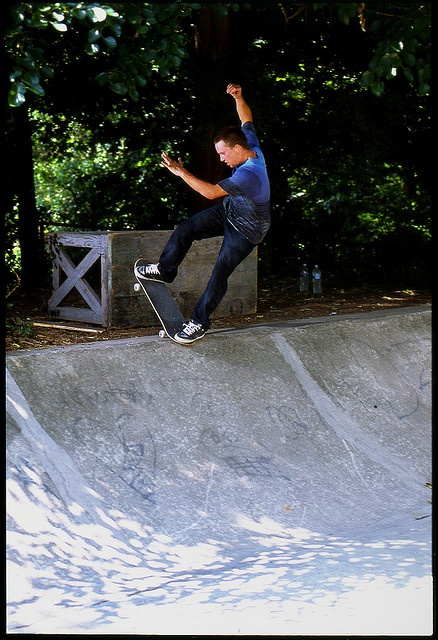Describe the objects in this image and their specific colors. I can see people in black, navy, and gray tones and skateboard in black and gray tones in this image. 